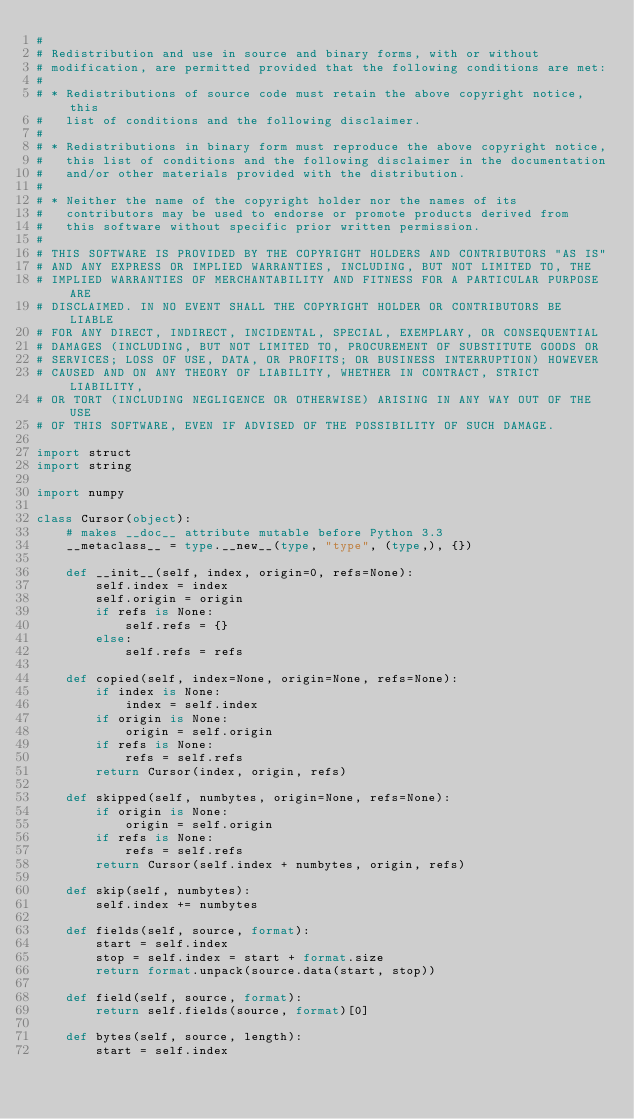Convert code to text. <code><loc_0><loc_0><loc_500><loc_500><_Python_>#
# Redistribution and use in source and binary forms, with or without
# modification, are permitted provided that the following conditions are met:
#
# * Redistributions of source code must retain the above copyright notice, this
#   list of conditions and the following disclaimer.
#
# * Redistributions in binary form must reproduce the above copyright notice,
#   this list of conditions and the following disclaimer in the documentation
#   and/or other materials provided with the distribution.
#
# * Neither the name of the copyright holder nor the names of its
#   contributors may be used to endorse or promote products derived from
#   this software without specific prior written permission.
#
# THIS SOFTWARE IS PROVIDED BY THE COPYRIGHT HOLDERS AND CONTRIBUTORS "AS IS"
# AND ANY EXPRESS OR IMPLIED WARRANTIES, INCLUDING, BUT NOT LIMITED TO, THE
# IMPLIED WARRANTIES OF MERCHANTABILITY AND FITNESS FOR A PARTICULAR PURPOSE ARE
# DISCLAIMED. IN NO EVENT SHALL THE COPYRIGHT HOLDER OR CONTRIBUTORS BE LIABLE
# FOR ANY DIRECT, INDIRECT, INCIDENTAL, SPECIAL, EXEMPLARY, OR CONSEQUENTIAL
# DAMAGES (INCLUDING, BUT NOT LIMITED TO, PROCUREMENT OF SUBSTITUTE GOODS OR
# SERVICES; LOSS OF USE, DATA, OR PROFITS; OR BUSINESS INTERRUPTION) HOWEVER
# CAUSED AND ON ANY THEORY OF LIABILITY, WHETHER IN CONTRACT, STRICT LIABILITY,
# OR TORT (INCLUDING NEGLIGENCE OR OTHERWISE) ARISING IN ANY WAY OUT OF THE USE
# OF THIS SOFTWARE, EVEN IF ADVISED OF THE POSSIBILITY OF SUCH DAMAGE.

import struct
import string

import numpy

class Cursor(object):
    # makes __doc__ attribute mutable before Python 3.3
    __metaclass__ = type.__new__(type, "type", (type,), {})

    def __init__(self, index, origin=0, refs=None):
        self.index = index
        self.origin = origin
        if refs is None:
            self.refs = {}
        else:
            self.refs = refs

    def copied(self, index=None, origin=None, refs=None):
        if index is None:
            index = self.index
        if origin is None:
            origin = self.origin
        if refs is None:
            refs = self.refs
        return Cursor(index, origin, refs)

    def skipped(self, numbytes, origin=None, refs=None):
        if origin is None:
            origin = self.origin
        if refs is None:
            refs = self.refs
        return Cursor(self.index + numbytes, origin, refs)

    def skip(self, numbytes):
        self.index += numbytes

    def fields(self, source, format):
        start = self.index
        stop = self.index = start + format.size
        return format.unpack(source.data(start, stop))

    def field(self, source, format):
        return self.fields(source, format)[0]

    def bytes(self, source, length):
        start = self.index</code> 